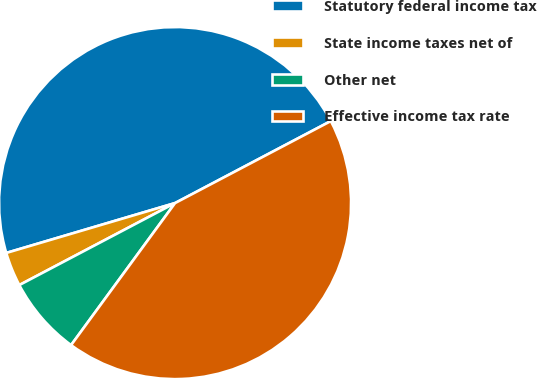Convert chart. <chart><loc_0><loc_0><loc_500><loc_500><pie_chart><fcel>Statutory federal income tax<fcel>State income taxes net of<fcel>Other net<fcel>Effective income tax rate<nl><fcel>46.86%<fcel>3.14%<fcel>7.23%<fcel>42.77%<nl></chart> 